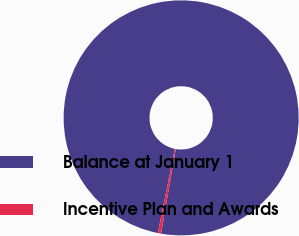<chart> <loc_0><loc_0><loc_500><loc_500><pie_chart><fcel>Balance at January 1<fcel>Incentive Plan and Awards<nl><fcel>99.56%<fcel>0.44%<nl></chart> 